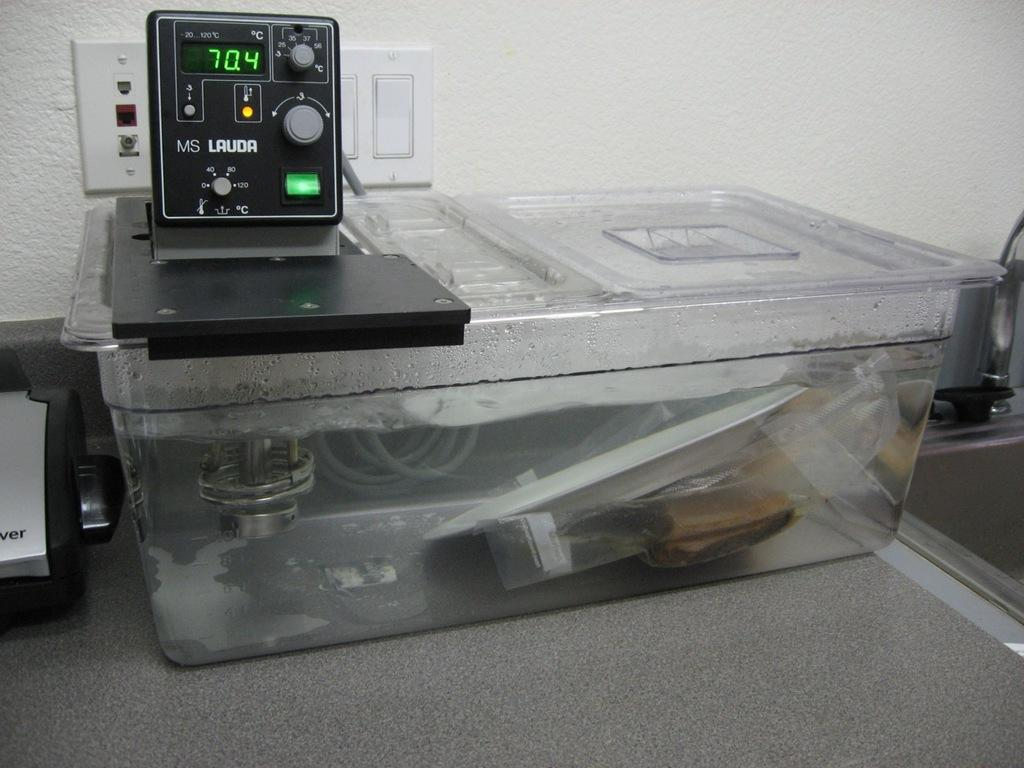<image>
Relay a brief, clear account of the picture shown. A circulator in a plastic container shows the temp 70.4 C. 